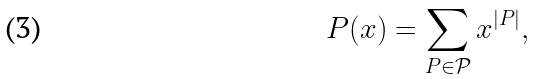Convert formula to latex. <formula><loc_0><loc_0><loc_500><loc_500>P ( x ) = \sum _ { P \in \mathcal { P } } x ^ { | P | } ,</formula> 